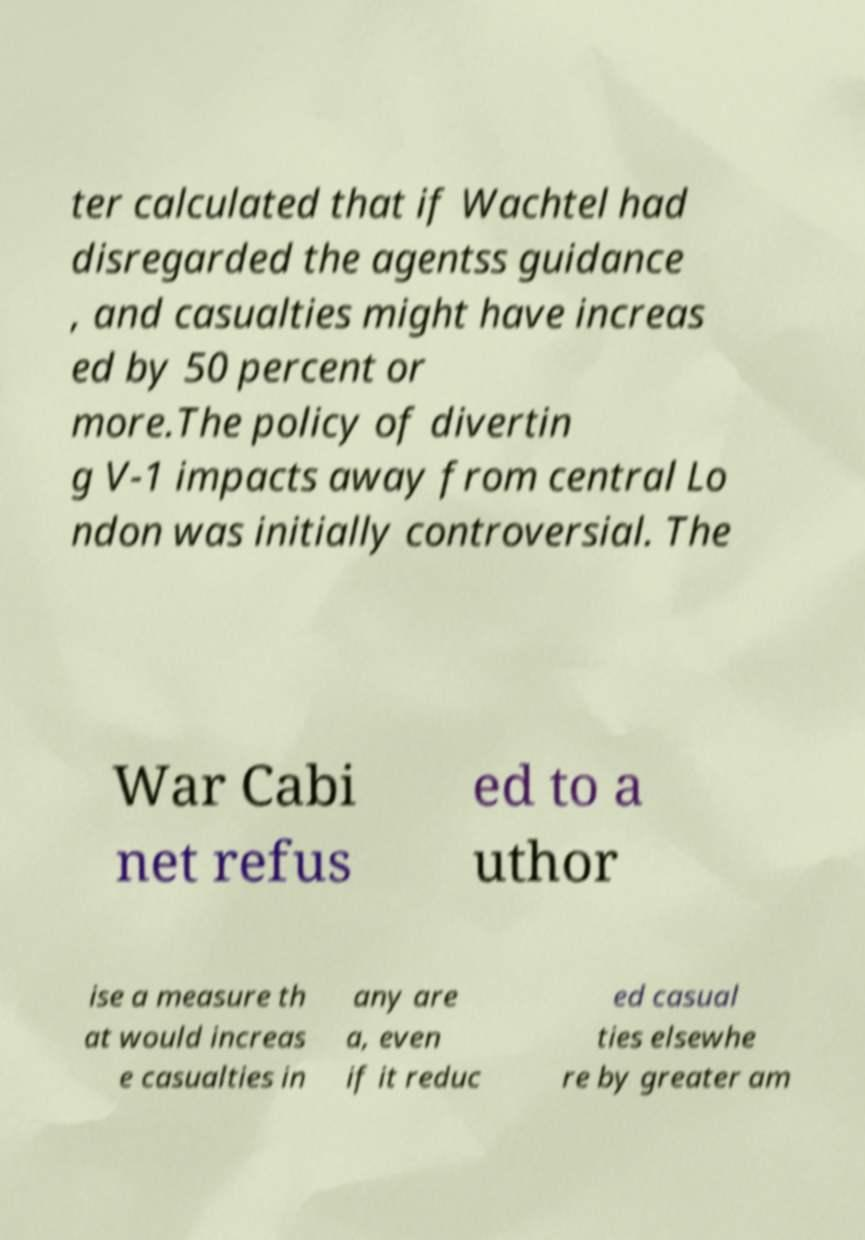What messages or text are displayed in this image? I need them in a readable, typed format. ter calculated that if Wachtel had disregarded the agentss guidance , and casualties might have increas ed by 50 percent or more.The policy of divertin g V-1 impacts away from central Lo ndon was initially controversial. The War Cabi net refus ed to a uthor ise a measure th at would increas e casualties in any are a, even if it reduc ed casual ties elsewhe re by greater am 